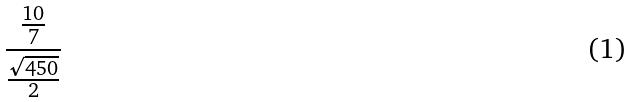<formula> <loc_0><loc_0><loc_500><loc_500>\frac { \frac { 1 0 } { 7 } } { \frac { \sqrt { 4 5 0 } } { 2 } }</formula> 